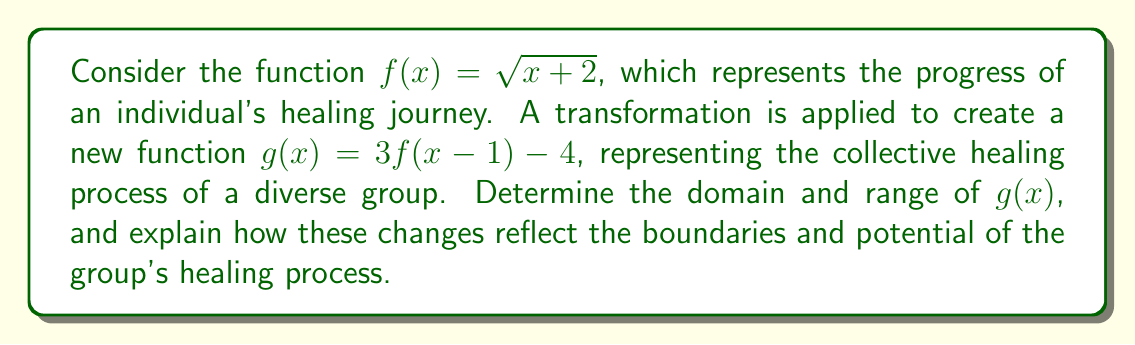Help me with this question. Let's approach this step-by-step:

1) First, let's consider the original function $f(x) = \sqrt{x + 2}$:
   Domain of $f(x)$: $x + 2 \geq 0$, so $x \geq -2$
   Range of $f(x)$: $y \geq 0$

2) Now, let's analyze the transformations applied to $f(x)$ to create $g(x)$:
   $g(x) = 3f(x - 1) - 4$
   
   a) Inside transformation: $(x - 1)$ shifts the function 1 unit right
   b) Outside transformations: Vertical stretch by factor of 3, then shift down 4 units

3) To find the domain of $g(x)$, we need to ensure the expression inside the square root is non-negative:
   $(x - 1) + 2 \geq 0$
   $x + 1 \geq 0$
   $x \geq -1$

4) For the range of $g(x)$, let's consider the transformations:
   - The original range of $f(x)$ is $y \geq 0$
   - Multiplying by 3 changes this to $y \geq 0$
   - Subtracting 4 shifts this down: $y \geq -4$

Therefore:
Domain of $g(x)$: $x \geq -1$
Range of $g(x)$: $y \geq -4$

These changes reflect the boundaries and potential of the group's healing process:
- The domain shift from $x \geq -2$ to $x \geq -1$ suggests that the collective healing process may have a higher starting point, possibly due to mutual support.
- The range expansion from $y \geq 0$ to $y \geq -4$ indicates a wider spectrum of healing experiences within the group, acknowledging both challenges (negative values) and progress.
- The vertical stretch by a factor of 3 implies that the group's collective effort may amplify individual healing progress.
Answer: Domain of $g(x)$: $x \geq -1$
Range of $g(x)$: $y \geq -4$ 